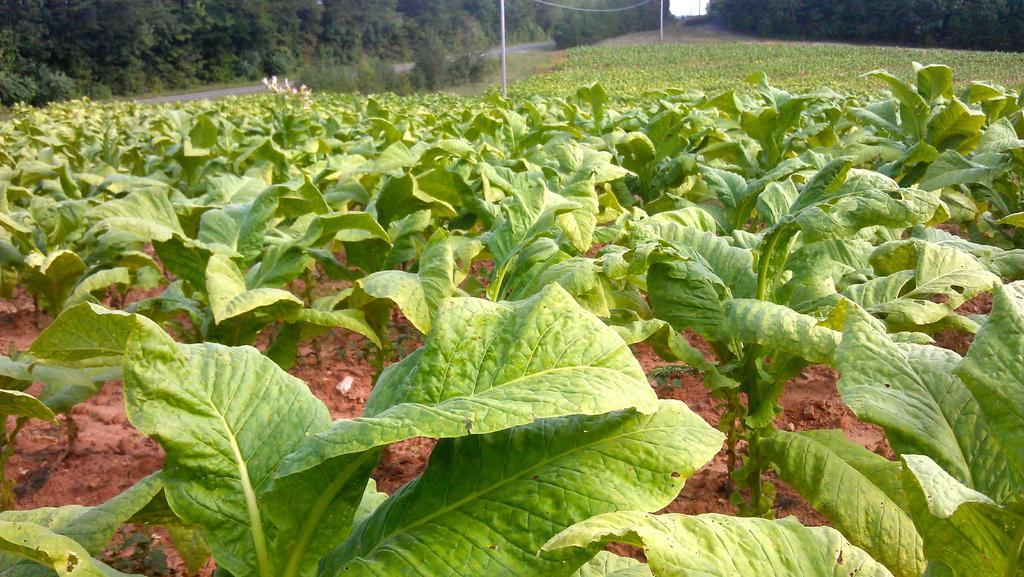What types of living organisms can be seen in the image? Plants and flowers are visible in the image. What is attached to the pole in the image? There is a thin wire attached to the pole in the image. What can be seen in the background of the image? Trees, a road, and the sky are visible in the background of the image. What month is it in the image? The month cannot be determined from the image, as there is no information about the time of year. Is there a cap visible in the image? There is no cap present in the image. 